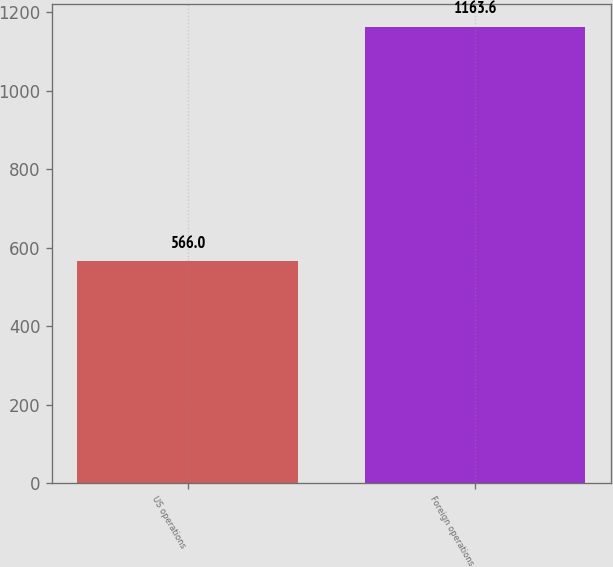Convert chart to OTSL. <chart><loc_0><loc_0><loc_500><loc_500><bar_chart><fcel>US operations<fcel>Foreign operations<nl><fcel>566<fcel>1163.6<nl></chart> 